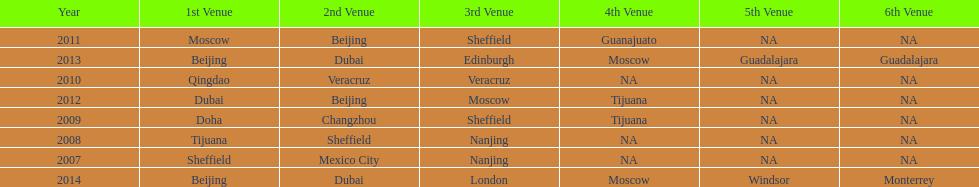How long, in years, has the this world series been occurring? 7 years. 